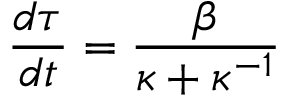Convert formula to latex. <formula><loc_0><loc_0><loc_500><loc_500>\frac { d \tau } { d t } = \frac { \beta } { \kappa + \kappa ^ { - 1 } }</formula> 